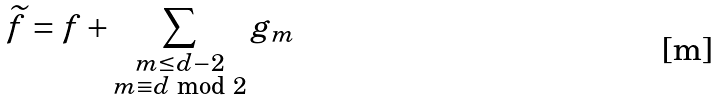<formula> <loc_0><loc_0><loc_500><loc_500>\widetilde { f } = f + \sum _ { \substack { m \leq d - 2 \\ m \equiv d \text { mod } 2 } } g _ { m }</formula> 